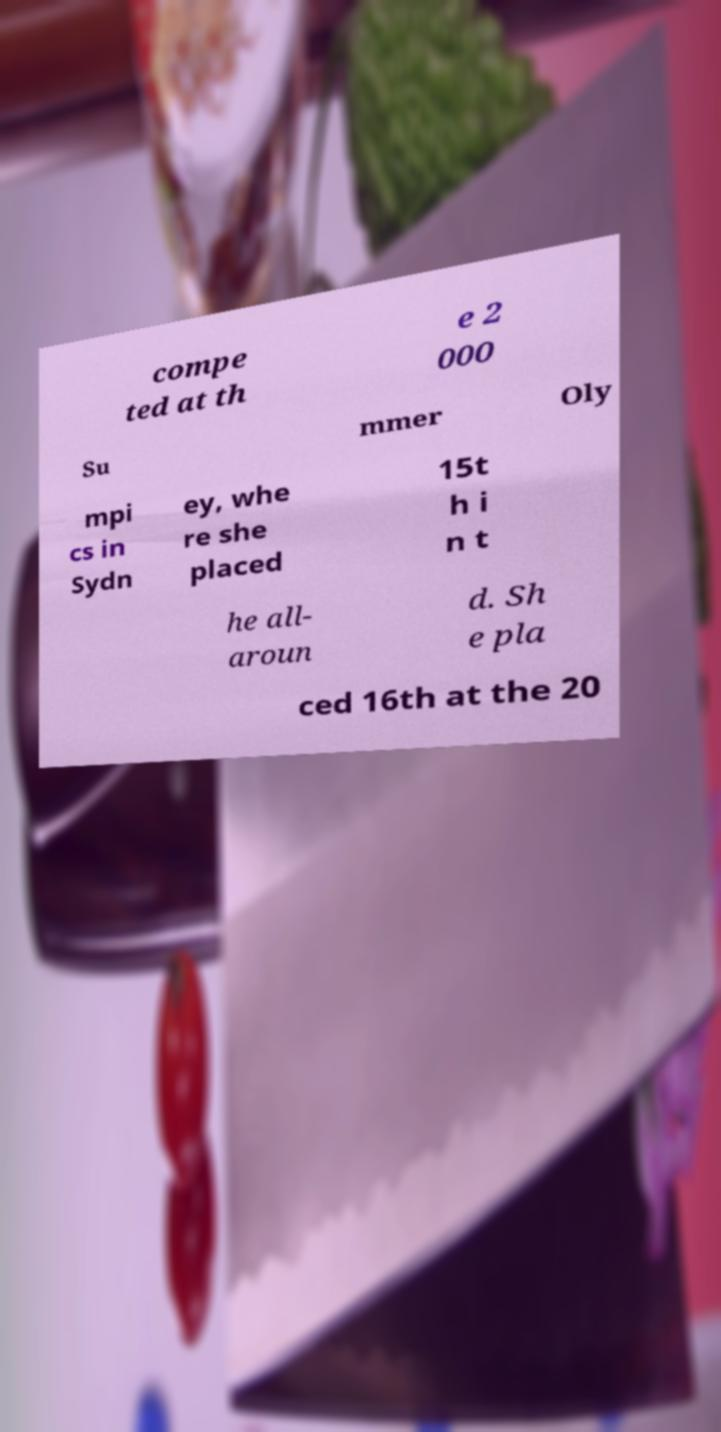What messages or text are displayed in this image? I need them in a readable, typed format. compe ted at th e 2 000 Su mmer Oly mpi cs in Sydn ey, whe re she placed 15t h i n t he all- aroun d. Sh e pla ced 16th at the 20 